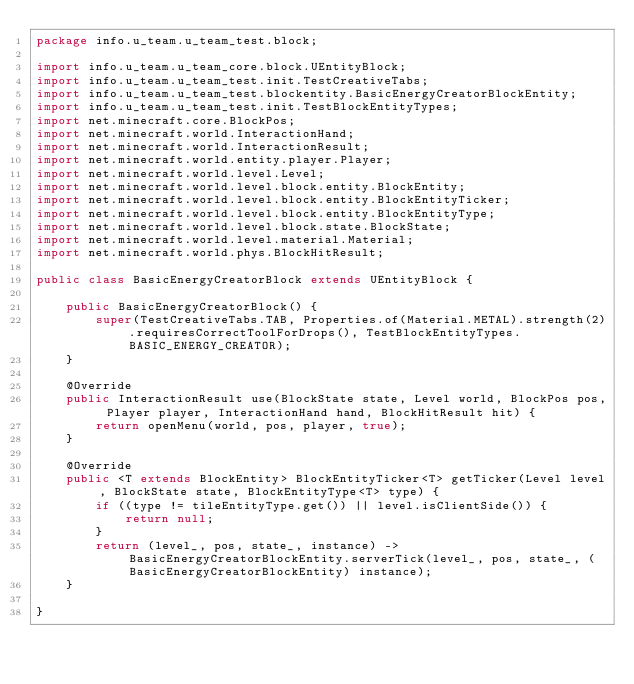<code> <loc_0><loc_0><loc_500><loc_500><_Java_>package info.u_team.u_team_test.block;

import info.u_team.u_team_core.block.UEntityBlock;
import info.u_team.u_team_test.init.TestCreativeTabs;
import info.u_team.u_team_test.blockentity.BasicEnergyCreatorBlockEntity;
import info.u_team.u_team_test.init.TestBlockEntityTypes;
import net.minecraft.core.BlockPos;
import net.minecraft.world.InteractionHand;
import net.minecraft.world.InteractionResult;
import net.minecraft.world.entity.player.Player;
import net.minecraft.world.level.Level;
import net.minecraft.world.level.block.entity.BlockEntity;
import net.minecraft.world.level.block.entity.BlockEntityTicker;
import net.minecraft.world.level.block.entity.BlockEntityType;
import net.minecraft.world.level.block.state.BlockState;
import net.minecraft.world.level.material.Material;
import net.minecraft.world.phys.BlockHitResult;

public class BasicEnergyCreatorBlock extends UEntityBlock {
	
	public BasicEnergyCreatorBlock() {
		super(TestCreativeTabs.TAB, Properties.of(Material.METAL).strength(2).requiresCorrectToolForDrops(), TestBlockEntityTypes.BASIC_ENERGY_CREATOR);
	}
	
	@Override
	public InteractionResult use(BlockState state, Level world, BlockPos pos, Player player, InteractionHand hand, BlockHitResult hit) {
		return openMenu(world, pos, player, true);
	}
	
	@Override
	public <T extends BlockEntity> BlockEntityTicker<T> getTicker(Level level, BlockState state, BlockEntityType<T> type) {
		if ((type != tileEntityType.get()) || level.isClientSide()) {
			return null;
		}
		return (level_, pos, state_, instance) -> BasicEnergyCreatorBlockEntity.serverTick(level_, pos, state_, (BasicEnergyCreatorBlockEntity) instance);
	}
	
}
</code> 